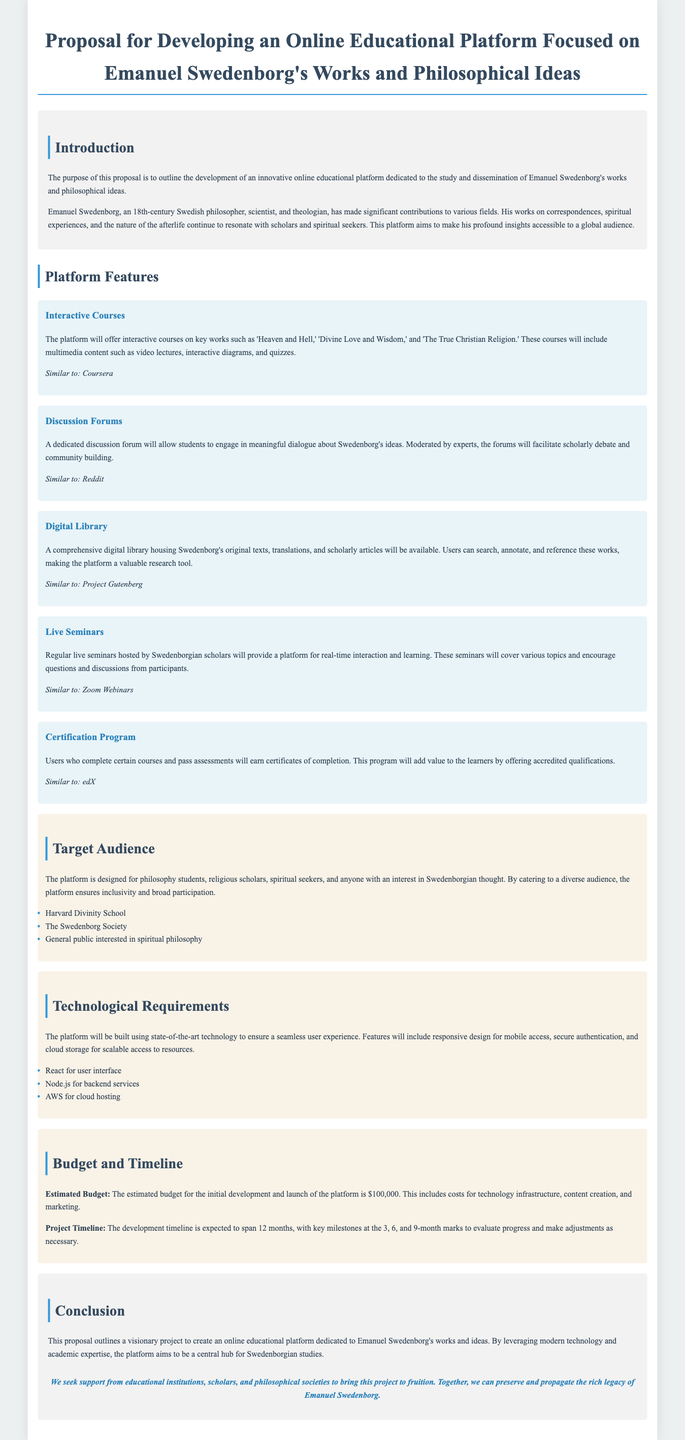What is the purpose of the proposal? The purpose of this proposal is to outline the development of an innovative online educational platform dedicated to the study and dissemination of Emanuel Swedenborg's works and philosophical ideas.
Answer: To outline the development of an innovative online educational platform What platforms are the interactive courses similar to? The interactive courses will use features that can be compared to other educational platforms mentioned in the document.
Answer: Coursera Who will moderate the discussion forums? The document specifies who will be responsible for moderating the forums, ensuring meaningful dialogue.
Answer: Experts What is included in the estimated budget for the platform? The estimated budget covers several areas related to the platform's development and launch.
Answer: Technology infrastructure, content creation, and marketing What programming language will be used for the backend services? The document mentions the technology that will be employed for backend services within the platform.
Answer: Node.js How long is the expected project timeline? The document outlines a specific duration for the project's progression toward completion.
Answer: 12 months What type of audiences is the platform targeting? The proposal identifies several groups that the educational platform is designed to include.
Answer: Philosophy students, religious scholars, spiritual seekers What is the estimated budget for the development and launch? The estimated budget is a key financial figure mentioned in the document for project initiation.
Answer: $100,000 